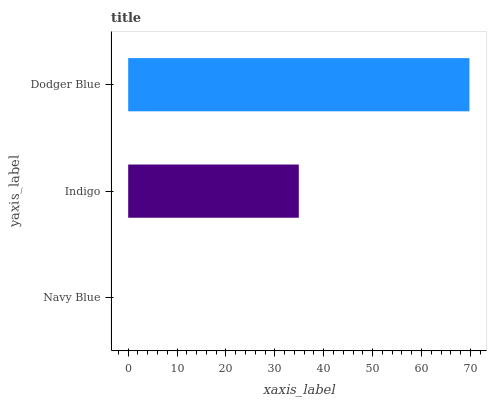Is Navy Blue the minimum?
Answer yes or no. Yes. Is Dodger Blue the maximum?
Answer yes or no. Yes. Is Indigo the minimum?
Answer yes or no. No. Is Indigo the maximum?
Answer yes or no. No. Is Indigo greater than Navy Blue?
Answer yes or no. Yes. Is Navy Blue less than Indigo?
Answer yes or no. Yes. Is Navy Blue greater than Indigo?
Answer yes or no. No. Is Indigo less than Navy Blue?
Answer yes or no. No. Is Indigo the high median?
Answer yes or no. Yes. Is Indigo the low median?
Answer yes or no. Yes. Is Dodger Blue the high median?
Answer yes or no. No. Is Dodger Blue the low median?
Answer yes or no. No. 